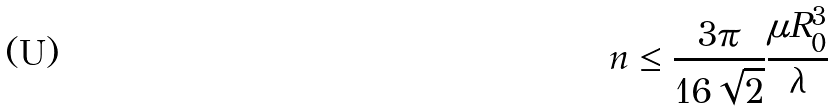<formula> <loc_0><loc_0><loc_500><loc_500>n \leq \frac { 3 \pi } { 1 6 \sqrt { 2 } } \frac { \mu R _ { 0 } ^ { 3 } } { \lambda }</formula> 